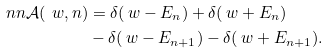Convert formula to latex. <formula><loc_0><loc_0><loc_500><loc_500>\ n n \mathcal { A } ( \ w , n ) & = \delta ( \ w - E _ { n } ) + \delta ( \ w + E _ { n } ) \\ & - \delta ( \ w - E _ { n + 1 } ) - \delta ( \ w + E _ { n + 1 } ) .</formula> 